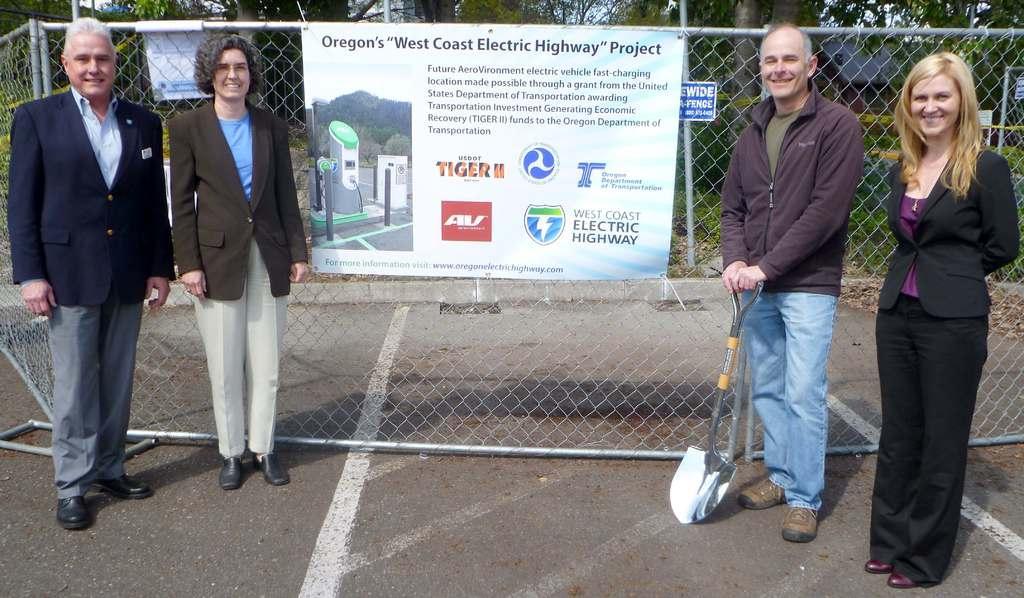Describe this image in one or two sentences. In this image there are few persons standing on the land. Left side two persons wearing suit are standing on the land. Right side there is a person holding a tool in his hand. Beside there is a woman standing. Behind them there is a fence having a board attached to it. Behind the fence there are few trees and plants. 